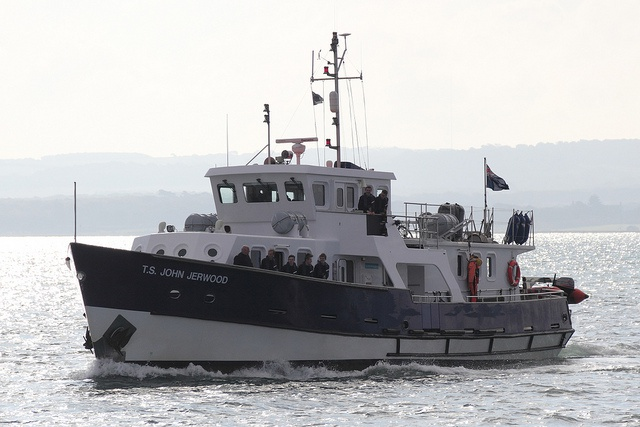Describe the objects in this image and their specific colors. I can see boat in white, gray, black, and lightgray tones, people in white, black, and gray tones, people in white, black, and gray tones, people in white, black, and gray tones, and people in white, black, and gray tones in this image. 